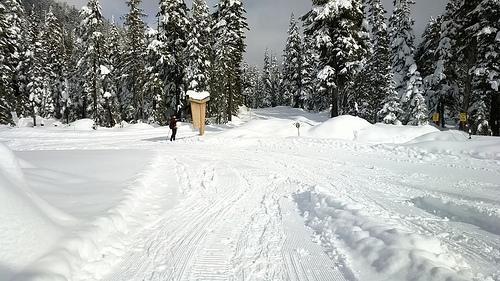How many people are in the picture?
Give a very brief answer. 1. 